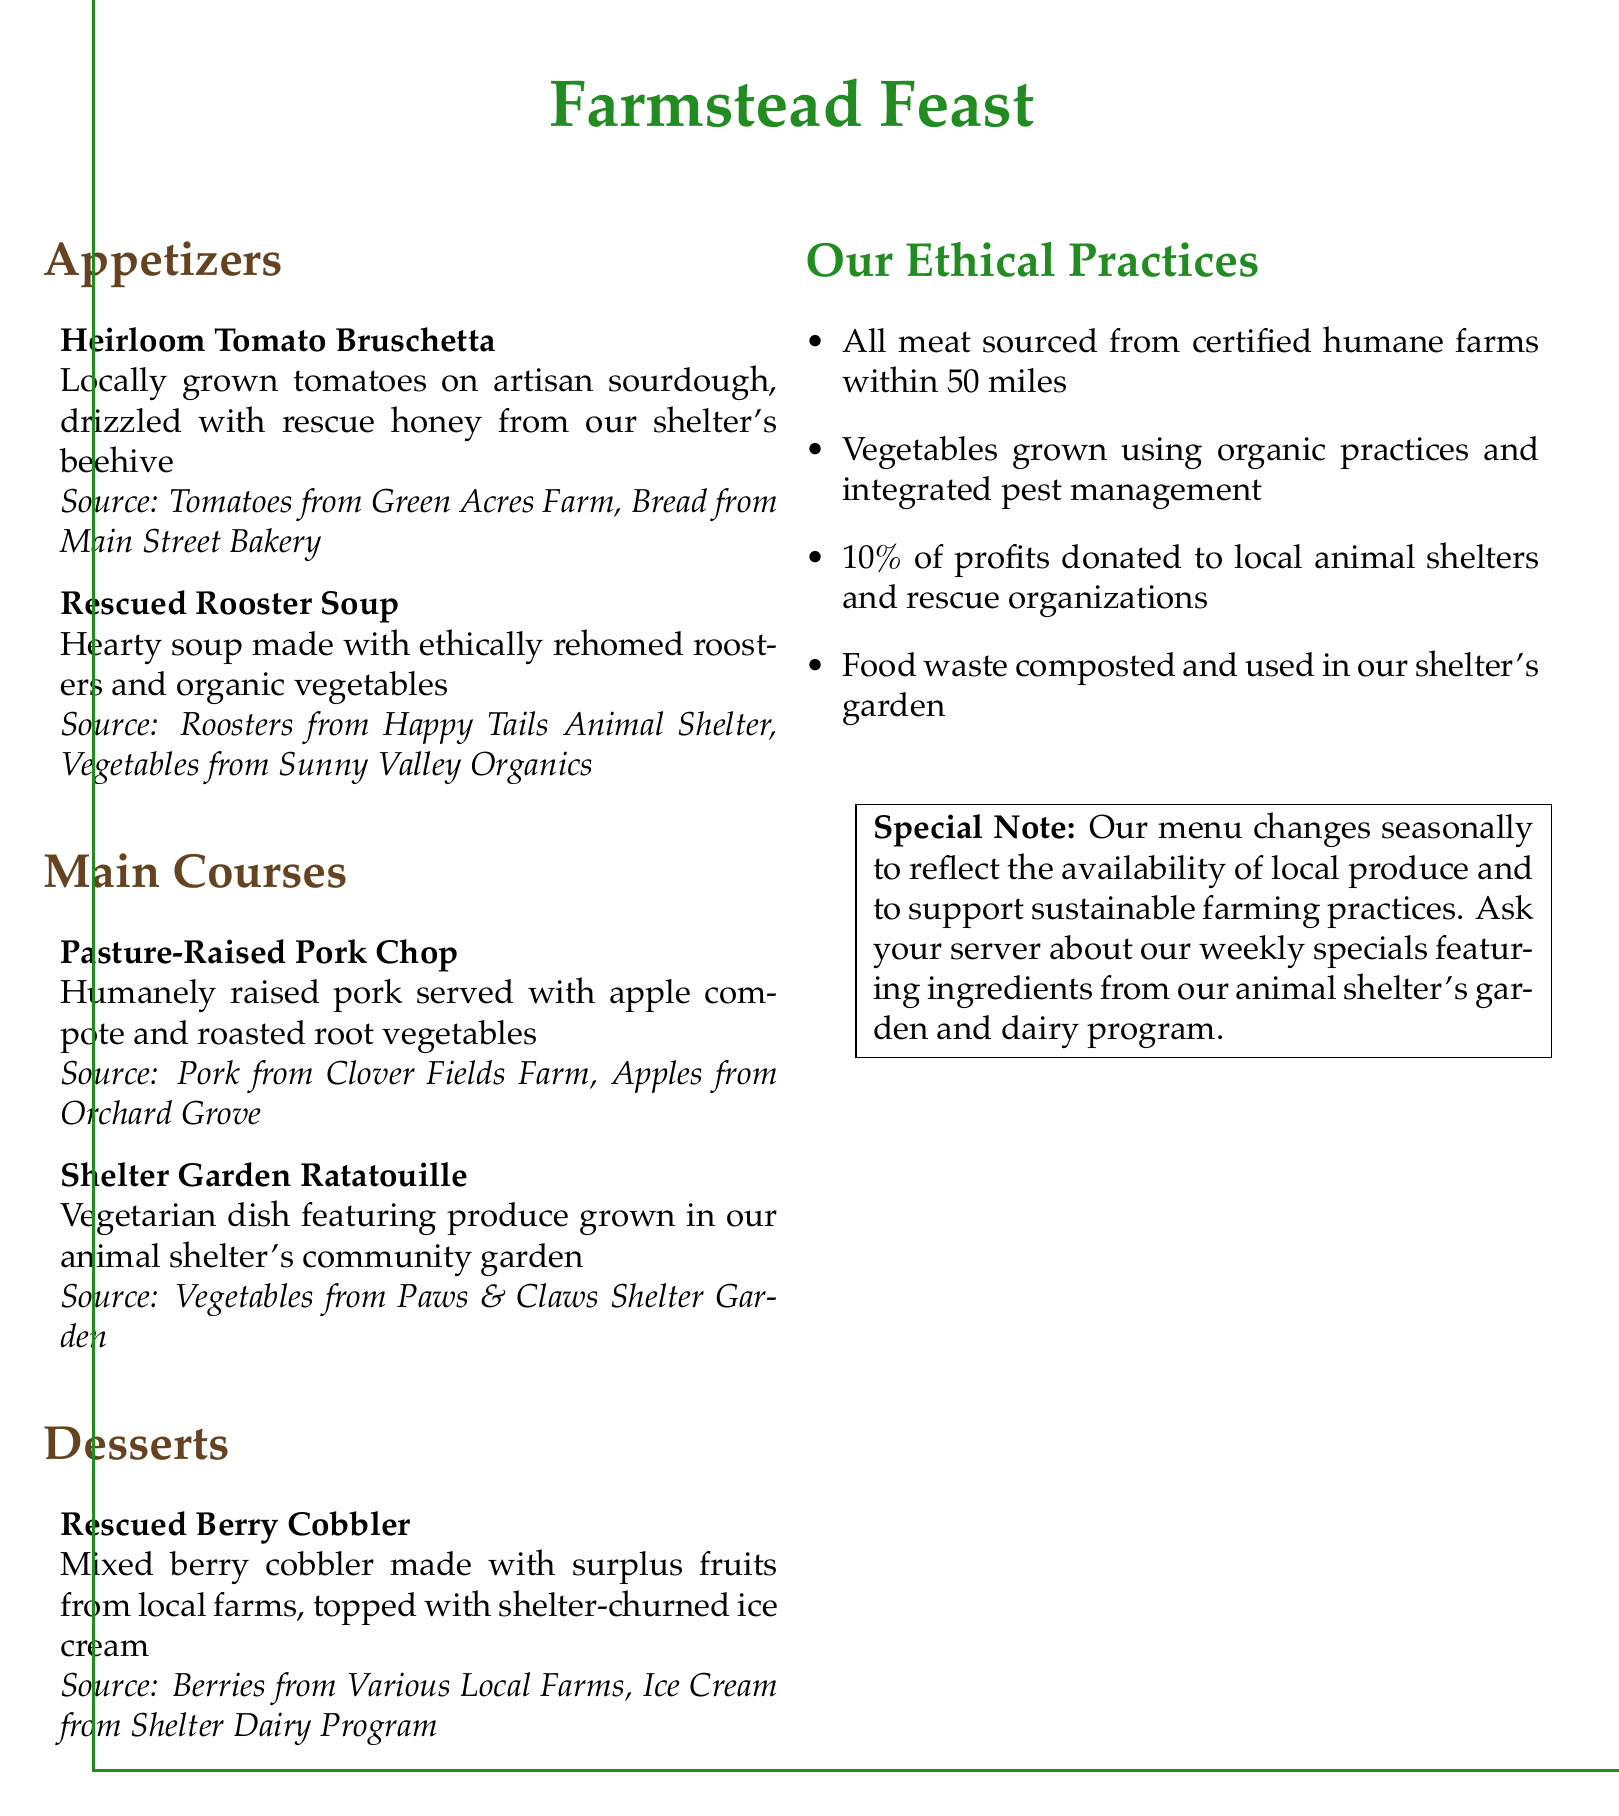What is the title of the menu? The title of the menu is presented prominently at the top of the document.
Answer: Farmstead Feast What is featured in the Heirloom Tomato Bruschetta? The Heirloom Tomato Bruschetta includes specific ingredients mentioned directly in the dish description.
Answer: Locally grown tomatoes Where do the ingredients for the Pasture-Raised Pork Chop come from? The source of the ingredients is listed for each dish, specifying where they are sourced from.
Answer: Clover Fields Farm, Orchard Grove What percentage of profits is donated to local shelters? The ethical practices section states the donation percentage, providing specific information about contributions.
Answer: 10% What type of vegetables are used in the Shelter Garden Ratatouille? The dish description clarifies the source of the vegetables used in this dish.
Answer: Produce grown in our animal shelter's community garden How often does the menu change? The special note at the bottom provides information about the frequency of menu changes based on ingredient availability.
Answer: Seasonally What do all meats on the menu have in common regarding their sourcing? The ethical practices outline a specific characteristic of the meat sourcing practices mentioned in the document.
Answer: Sourced from certified humane farms Which dessert uses surplus fruits from local farms? The specific dessert description indicates the source of the fruits used in the dessert.
Answer: Rescued Berry Cobbler 